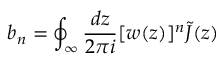<formula> <loc_0><loc_0><loc_500><loc_500>b _ { n } = \oint _ { \infty } \frac { d z } { 2 \pi i } [ w ( z ) ] ^ { n } \tilde { J } ( z )</formula> 